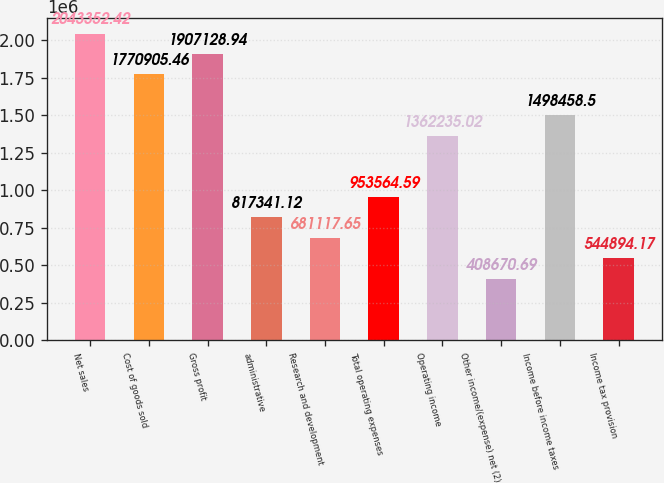<chart> <loc_0><loc_0><loc_500><loc_500><bar_chart><fcel>Net sales<fcel>Cost of goods sold<fcel>Gross profit<fcel>administrative<fcel>Research and development<fcel>Total operating expenses<fcel>Operating income<fcel>Other income/(expense) net (2)<fcel>Income before income taxes<fcel>Income tax provision<nl><fcel>2.04335e+06<fcel>1.77091e+06<fcel>1.90713e+06<fcel>817341<fcel>681118<fcel>953565<fcel>1.36224e+06<fcel>408671<fcel>1.49846e+06<fcel>544894<nl></chart> 